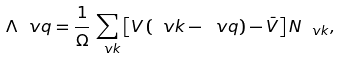<formula> <loc_0><loc_0><loc_500><loc_500>\Lambda _ { \ } v q = \frac { 1 } { \Omega } \sum _ { \ v k } \left [ V \left ( \ v k - \ v q \right ) - \bar { V } \right ] N _ { \ v k } ,</formula> 